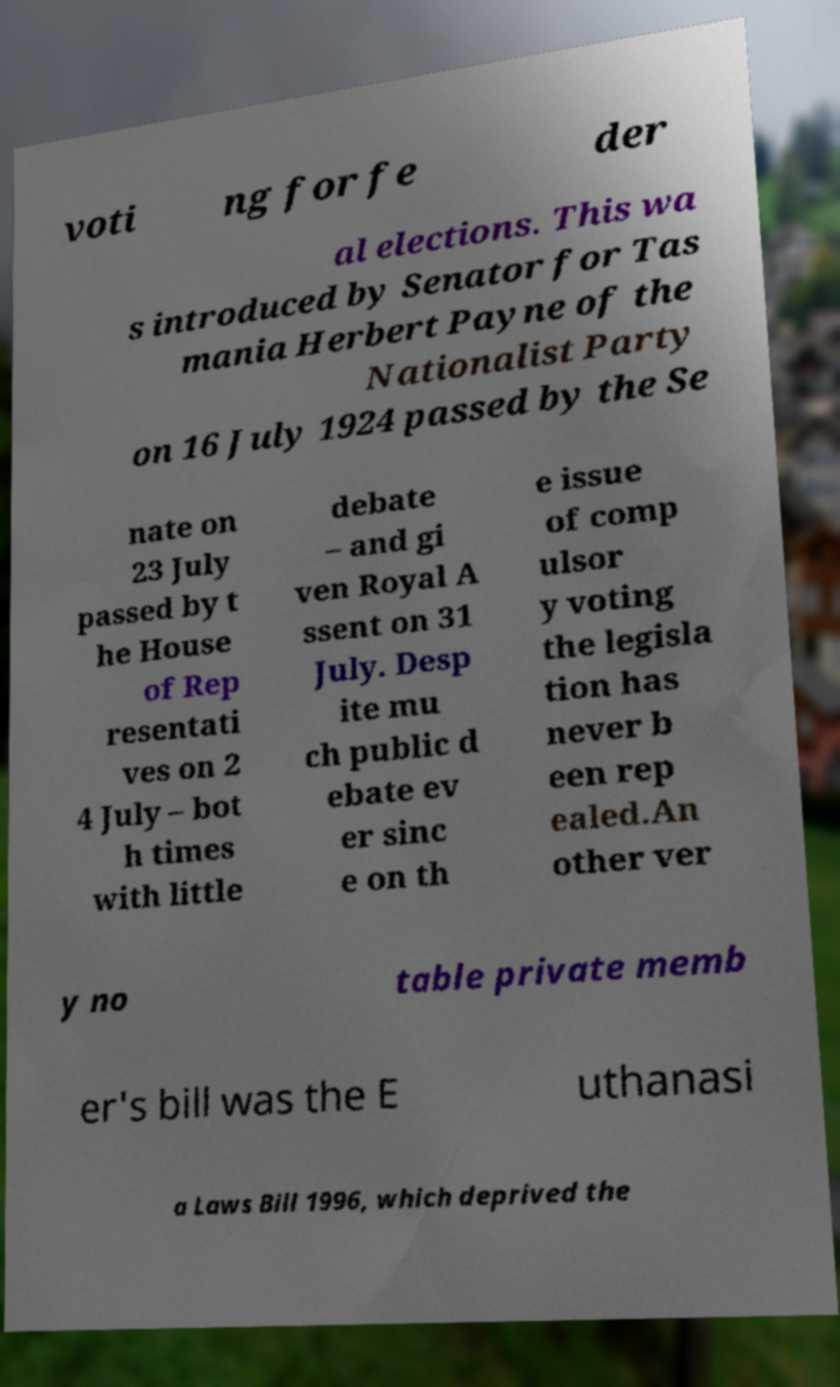There's text embedded in this image that I need extracted. Can you transcribe it verbatim? voti ng for fe der al elections. This wa s introduced by Senator for Tas mania Herbert Payne of the Nationalist Party on 16 July 1924 passed by the Se nate on 23 July passed by t he House of Rep resentati ves on 2 4 July – bot h times with little debate – and gi ven Royal A ssent on 31 July. Desp ite mu ch public d ebate ev er sinc e on th e issue of comp ulsor y voting the legisla tion has never b een rep ealed.An other ver y no table private memb er's bill was the E uthanasi a Laws Bill 1996, which deprived the 